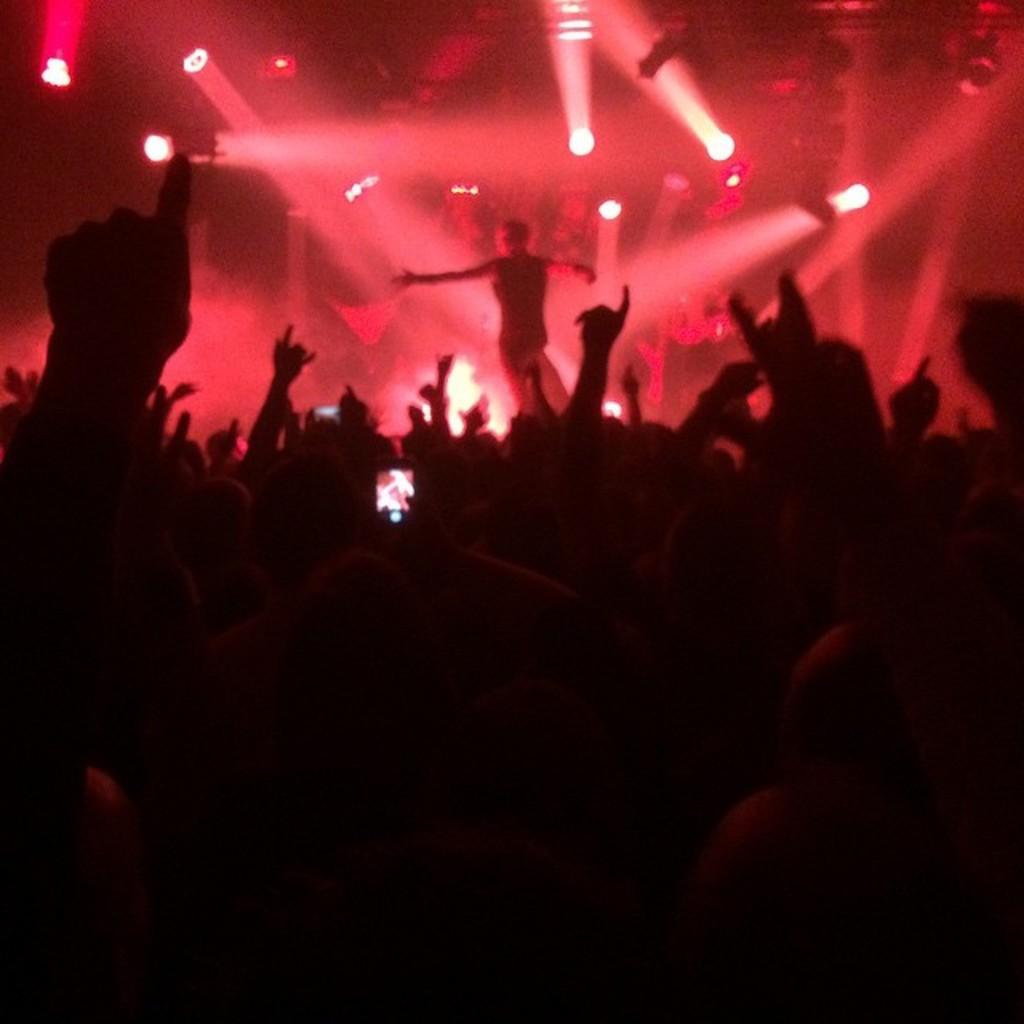Could you give a brief overview of what you see in this image? In the center of the image there are people. In the background of the image there are lights. 